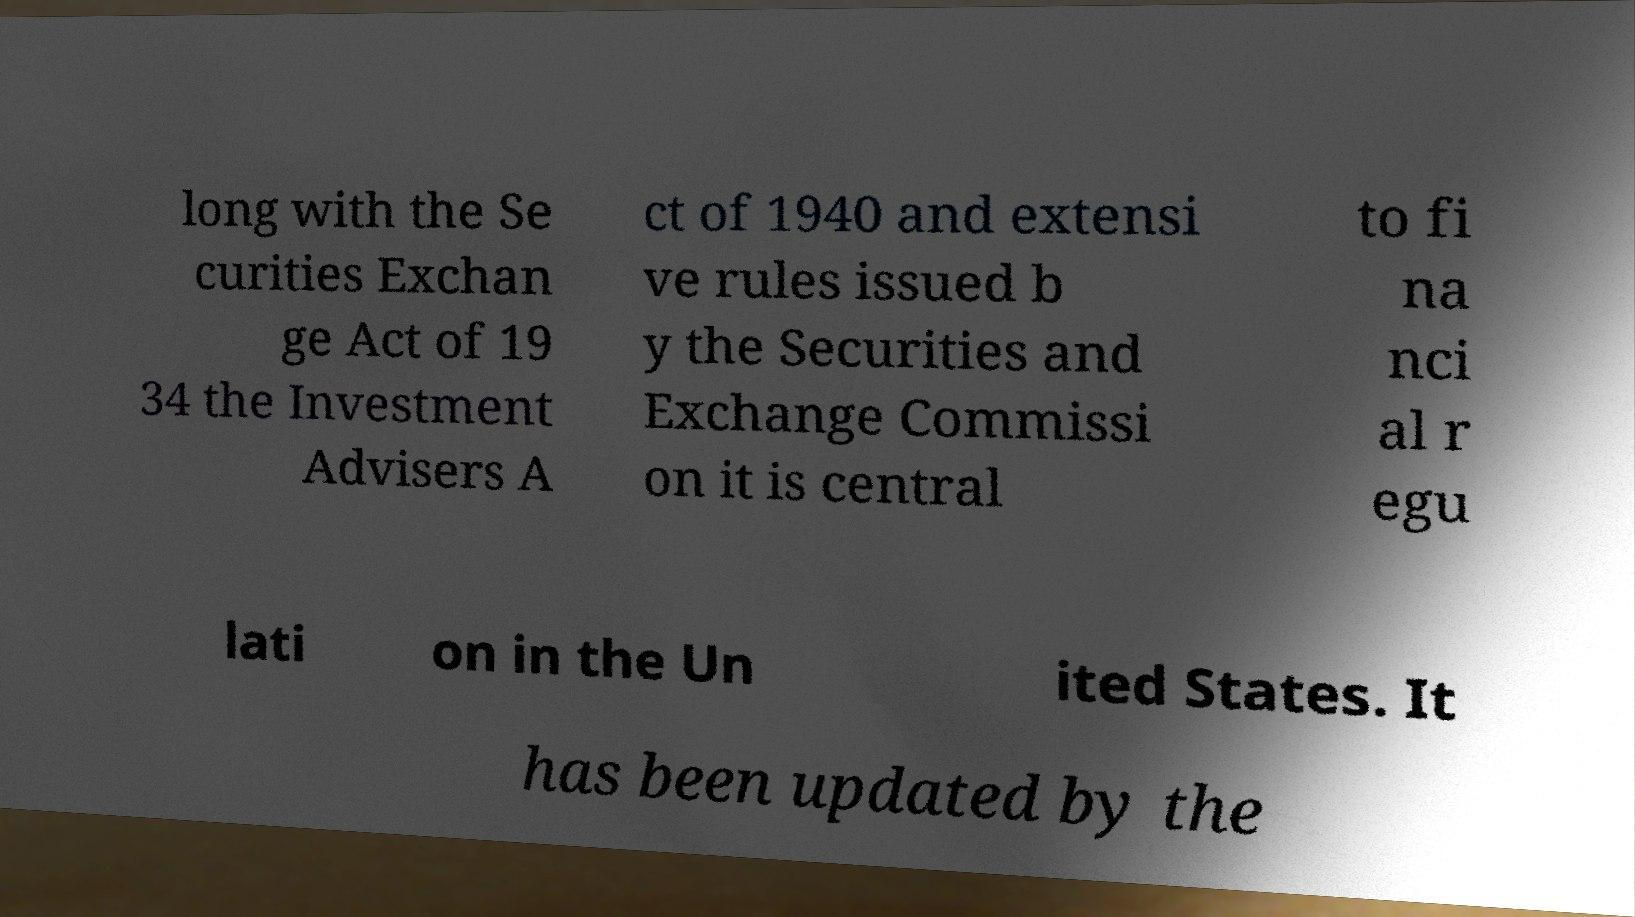Can you read and provide the text displayed in the image?This photo seems to have some interesting text. Can you extract and type it out for me? long with the Se curities Exchan ge Act of 19 34 the Investment Advisers A ct of 1940 and extensi ve rules issued b y the Securities and Exchange Commissi on it is central to fi na nci al r egu lati on in the Un ited States. It has been updated by the 